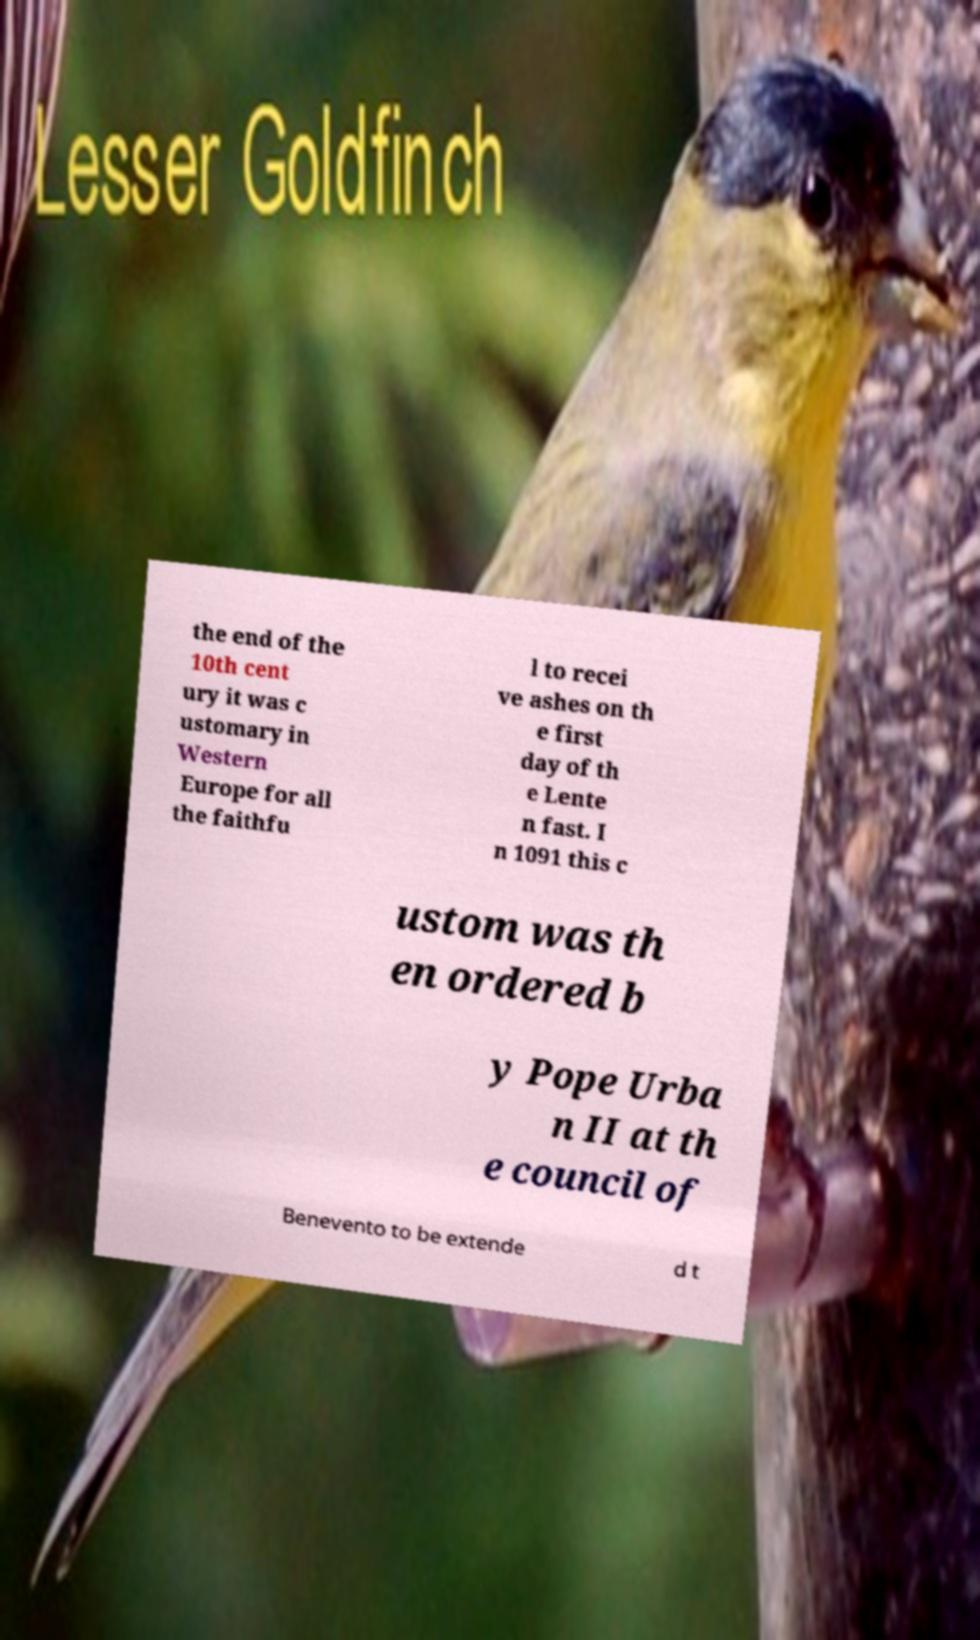I need the written content from this picture converted into text. Can you do that? the end of the 10th cent ury it was c ustomary in Western Europe for all the faithfu l to recei ve ashes on th e first day of th e Lente n fast. I n 1091 this c ustom was th en ordered b y Pope Urba n II at th e council of Benevento to be extende d t 